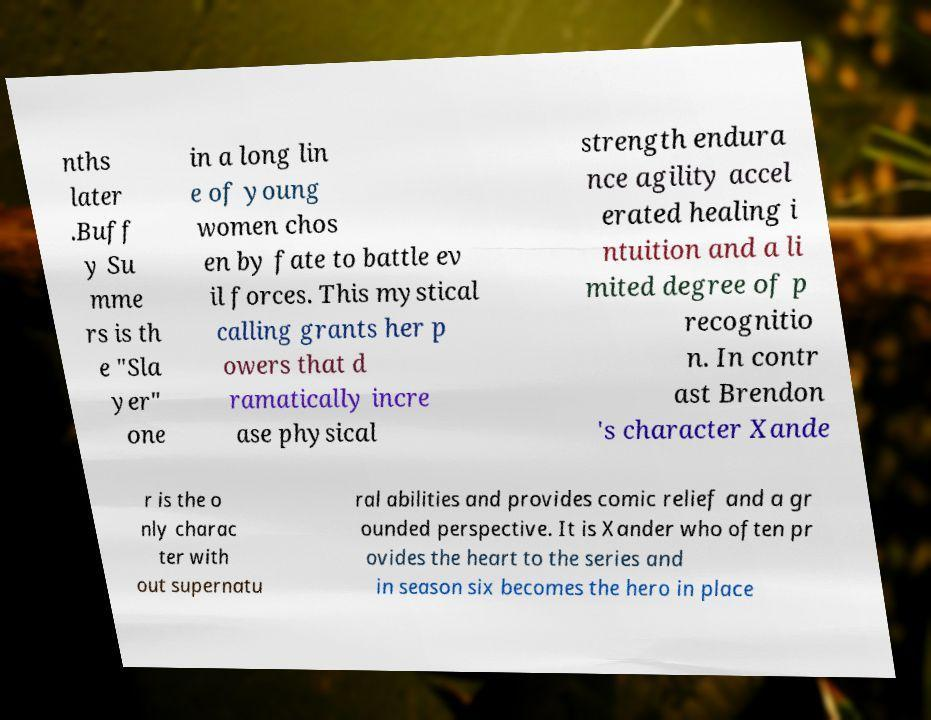I need the written content from this picture converted into text. Can you do that? nths later .Buff y Su mme rs is th e "Sla yer" one in a long lin e of young women chos en by fate to battle ev il forces. This mystical calling grants her p owers that d ramatically incre ase physical strength endura nce agility accel erated healing i ntuition and a li mited degree of p recognitio n. In contr ast Brendon 's character Xande r is the o nly charac ter with out supernatu ral abilities and provides comic relief and a gr ounded perspective. It is Xander who often pr ovides the heart to the series and in season six becomes the hero in place 